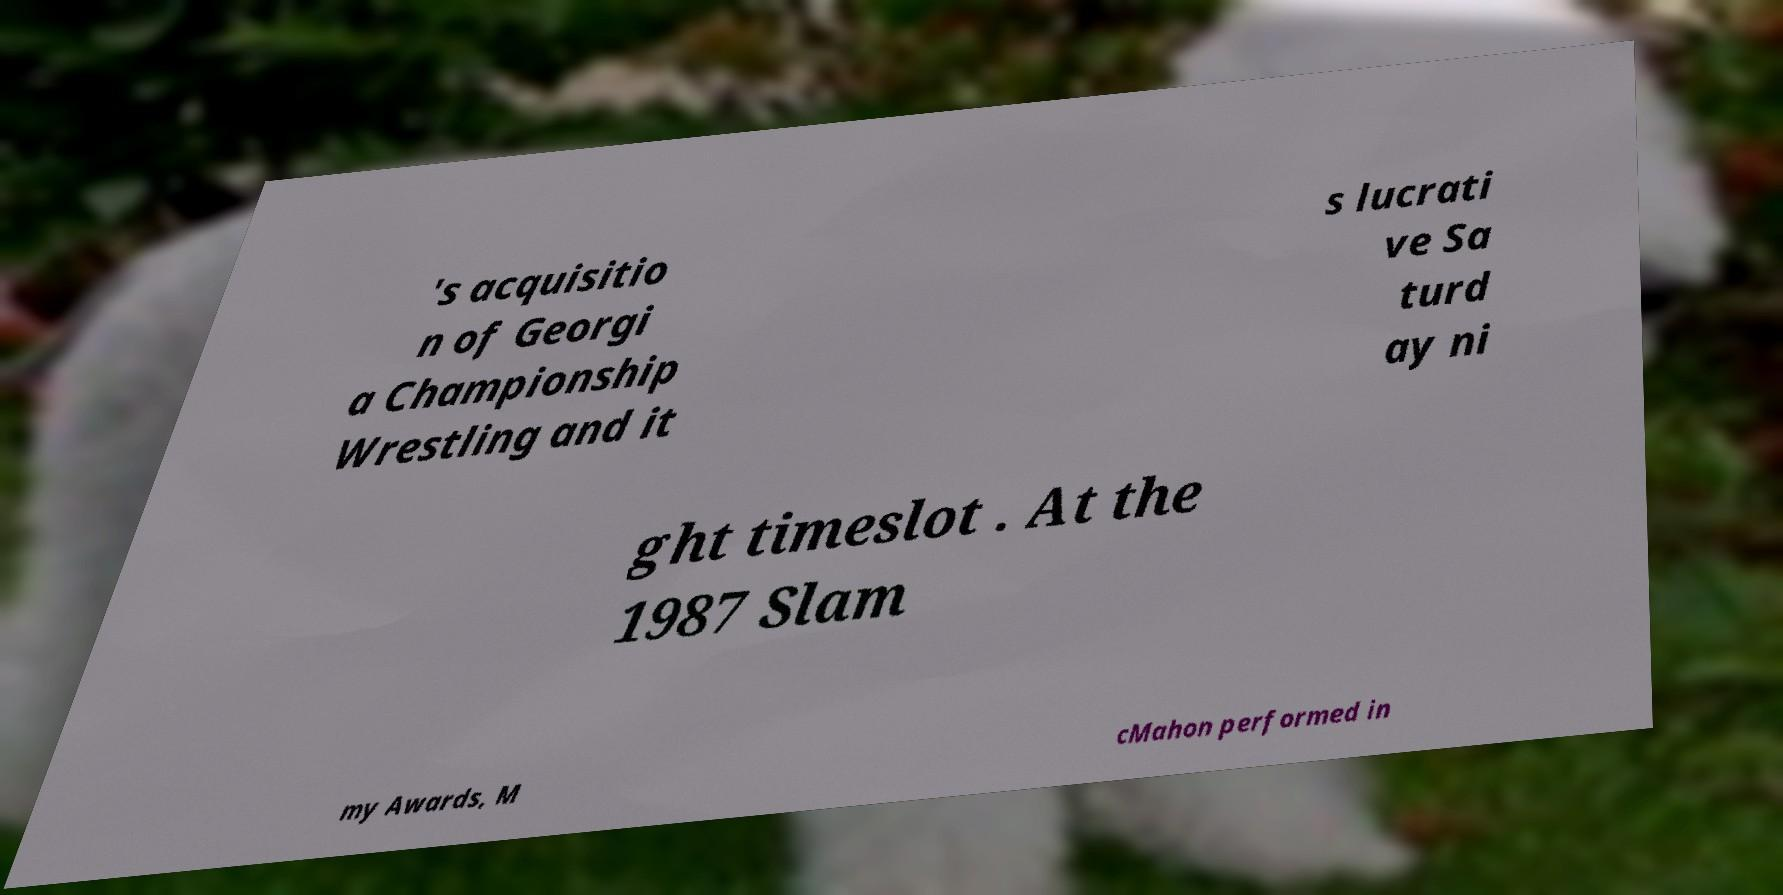For documentation purposes, I need the text within this image transcribed. Could you provide that? 's acquisitio n of Georgi a Championship Wrestling and it s lucrati ve Sa turd ay ni ght timeslot . At the 1987 Slam my Awards, M cMahon performed in 